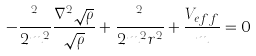Convert formula to latex. <formula><loc_0><loc_0><loc_500><loc_500>- \frac { { } ^ { 2 } } { 2 m ^ { 2 } } \frac { { \nabla } ^ { 2 } { \sqrt { \rho } } } { \sqrt { \rho } } + \frac { { } ^ { 2 } } { 2 m ^ { 2 } r ^ { 2 } } + \frac { V _ { e f f } } { m } = 0</formula> 